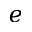Convert formula to latex. <formula><loc_0><loc_0><loc_500><loc_500>e</formula> 